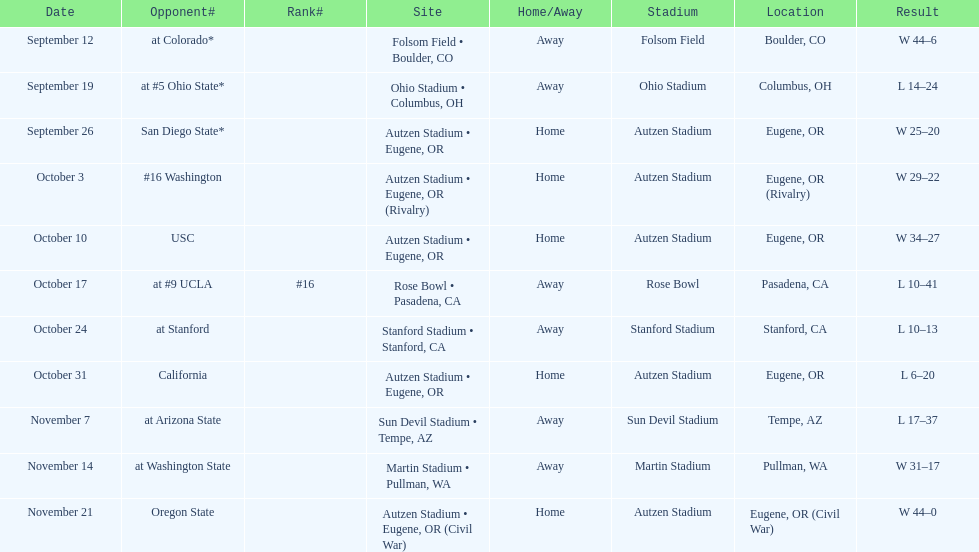Who was their last opponent of the season? Oregon State. 